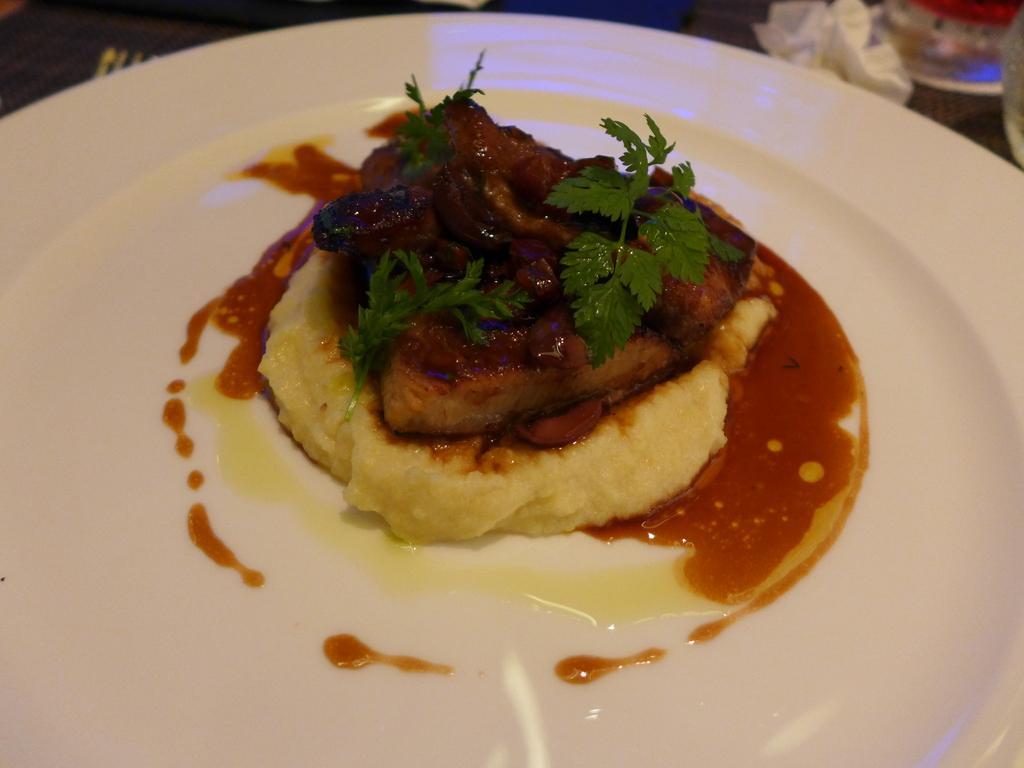Can you describe this image briefly? In this image we can see food items in plate. 